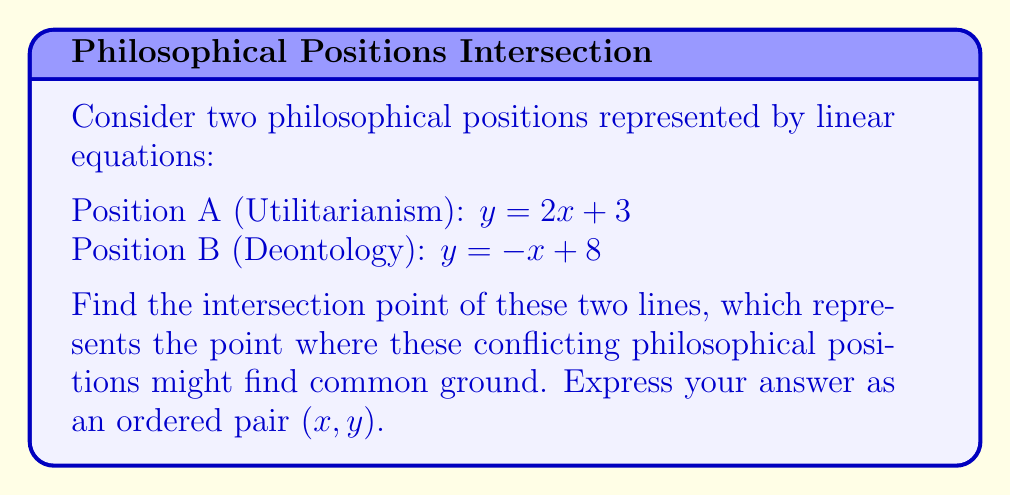Could you help me with this problem? To find the intersection point of two lines, we need to solve the system of equations:

$$\begin{cases}
y = 2x + 3 \\
y = -x + 8
\end{cases}$$

Step 1: Set the two equations equal to each other since they represent the same y-value at the intersection point.
$2x + 3 = -x + 8$

Step 2: Solve for x by combining like terms and isolating the variable.
$2x + x = 8 - 3$
$3x = 5$
$x = \frac{5}{3}$

Step 3: Substitute this x-value into either of the original equations to find y. Let's use the first equation:
$y = 2(\frac{5}{3}) + 3$
$y = \frac{10}{3} + 3$
$y = \frac{10}{3} + \frac{9}{3}$
$y = \frac{19}{3}$

Step 4: Express the solution as an ordered pair $(x, y)$.
$(\frac{5}{3}, \frac{19}{3})$

This point represents where the two philosophical positions intersect, potentially indicating a area of agreement or compromise between Utilitarianism and Deontology.
Answer: $(\frac{5}{3}, \frac{19}{3})$ 